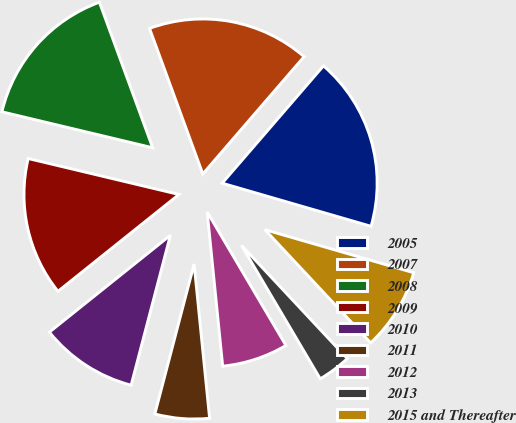Convert chart to OTSL. <chart><loc_0><loc_0><loc_500><loc_500><pie_chart><fcel>2005<fcel>2007<fcel>2008<fcel>2009<fcel>2010<fcel>2011<fcel>2012<fcel>2013<fcel>2015 and Thereafter<nl><fcel>18.15%<fcel>16.92%<fcel>15.69%<fcel>14.47%<fcel>10.18%<fcel>5.67%<fcel>6.89%<fcel>3.48%<fcel>8.55%<nl></chart> 